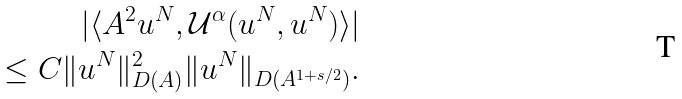<formula> <loc_0><loc_0><loc_500><loc_500>| \langle A ^ { 2 } u ^ { N } , \mathcal { U } ^ { \alpha } ( u ^ { N } , u ^ { N } ) \rangle | \\ \leq C \| u ^ { N } \| _ { D ( A ) } ^ { 2 } \| u ^ { N } \| _ { D ( A ^ { 1 + s / 2 } ) } .</formula> 